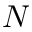Convert formula to latex. <formula><loc_0><loc_0><loc_500><loc_500>N</formula> 